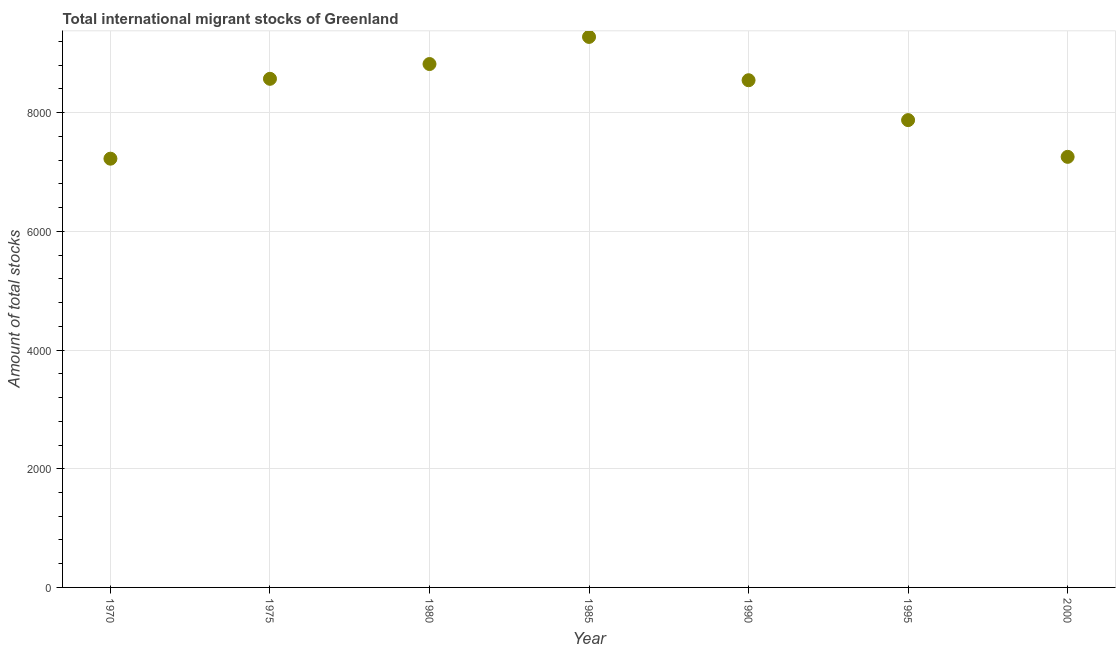What is the total number of international migrant stock in 1990?
Offer a terse response. 8547. Across all years, what is the maximum total number of international migrant stock?
Offer a terse response. 9277. Across all years, what is the minimum total number of international migrant stock?
Provide a short and direct response. 7225. In which year was the total number of international migrant stock maximum?
Your answer should be compact. 1985. What is the sum of the total number of international migrant stock?
Offer a terse response. 5.76e+04. What is the difference between the total number of international migrant stock in 1970 and 1980?
Make the answer very short. -1595. What is the average total number of international migrant stock per year?
Keep it short and to the point. 8224.43. What is the median total number of international migrant stock?
Offer a terse response. 8547. In how many years, is the total number of international migrant stock greater than 4400 ?
Provide a short and direct response. 7. What is the ratio of the total number of international migrant stock in 1975 to that in 1990?
Make the answer very short. 1. Is the difference between the total number of international migrant stock in 1970 and 1975 greater than the difference between any two years?
Give a very brief answer. No. What is the difference between the highest and the second highest total number of international migrant stock?
Your answer should be compact. 457. Is the sum of the total number of international migrant stock in 1970 and 1985 greater than the maximum total number of international migrant stock across all years?
Offer a very short reply. Yes. What is the difference between the highest and the lowest total number of international migrant stock?
Offer a terse response. 2052. Does the total number of international migrant stock monotonically increase over the years?
Offer a terse response. No. How many dotlines are there?
Offer a very short reply. 1. How many years are there in the graph?
Ensure brevity in your answer.  7. Does the graph contain any zero values?
Offer a very short reply. No. What is the title of the graph?
Provide a short and direct response. Total international migrant stocks of Greenland. What is the label or title of the Y-axis?
Your answer should be compact. Amount of total stocks. What is the Amount of total stocks in 1970?
Ensure brevity in your answer.  7225. What is the Amount of total stocks in 1975?
Give a very brief answer. 8571. What is the Amount of total stocks in 1980?
Your response must be concise. 8820. What is the Amount of total stocks in 1985?
Provide a short and direct response. 9277. What is the Amount of total stocks in 1990?
Keep it short and to the point. 8547. What is the Amount of total stocks in 1995?
Provide a succinct answer. 7875. What is the Amount of total stocks in 2000?
Your answer should be very brief. 7256. What is the difference between the Amount of total stocks in 1970 and 1975?
Make the answer very short. -1346. What is the difference between the Amount of total stocks in 1970 and 1980?
Your answer should be very brief. -1595. What is the difference between the Amount of total stocks in 1970 and 1985?
Offer a terse response. -2052. What is the difference between the Amount of total stocks in 1970 and 1990?
Give a very brief answer. -1322. What is the difference between the Amount of total stocks in 1970 and 1995?
Provide a short and direct response. -650. What is the difference between the Amount of total stocks in 1970 and 2000?
Your answer should be compact. -31. What is the difference between the Amount of total stocks in 1975 and 1980?
Provide a short and direct response. -249. What is the difference between the Amount of total stocks in 1975 and 1985?
Your answer should be very brief. -706. What is the difference between the Amount of total stocks in 1975 and 1995?
Offer a terse response. 696. What is the difference between the Amount of total stocks in 1975 and 2000?
Provide a succinct answer. 1315. What is the difference between the Amount of total stocks in 1980 and 1985?
Keep it short and to the point. -457. What is the difference between the Amount of total stocks in 1980 and 1990?
Offer a terse response. 273. What is the difference between the Amount of total stocks in 1980 and 1995?
Your response must be concise. 945. What is the difference between the Amount of total stocks in 1980 and 2000?
Your answer should be very brief. 1564. What is the difference between the Amount of total stocks in 1985 and 1990?
Your answer should be very brief. 730. What is the difference between the Amount of total stocks in 1985 and 1995?
Give a very brief answer. 1402. What is the difference between the Amount of total stocks in 1985 and 2000?
Make the answer very short. 2021. What is the difference between the Amount of total stocks in 1990 and 1995?
Your response must be concise. 672. What is the difference between the Amount of total stocks in 1990 and 2000?
Provide a succinct answer. 1291. What is the difference between the Amount of total stocks in 1995 and 2000?
Give a very brief answer. 619. What is the ratio of the Amount of total stocks in 1970 to that in 1975?
Give a very brief answer. 0.84. What is the ratio of the Amount of total stocks in 1970 to that in 1980?
Your answer should be compact. 0.82. What is the ratio of the Amount of total stocks in 1970 to that in 1985?
Your response must be concise. 0.78. What is the ratio of the Amount of total stocks in 1970 to that in 1990?
Ensure brevity in your answer.  0.84. What is the ratio of the Amount of total stocks in 1970 to that in 1995?
Provide a succinct answer. 0.92. What is the ratio of the Amount of total stocks in 1970 to that in 2000?
Offer a terse response. 1. What is the ratio of the Amount of total stocks in 1975 to that in 1980?
Provide a short and direct response. 0.97. What is the ratio of the Amount of total stocks in 1975 to that in 1985?
Give a very brief answer. 0.92. What is the ratio of the Amount of total stocks in 1975 to that in 1995?
Make the answer very short. 1.09. What is the ratio of the Amount of total stocks in 1975 to that in 2000?
Ensure brevity in your answer.  1.18. What is the ratio of the Amount of total stocks in 1980 to that in 1985?
Your response must be concise. 0.95. What is the ratio of the Amount of total stocks in 1980 to that in 1990?
Your answer should be very brief. 1.03. What is the ratio of the Amount of total stocks in 1980 to that in 1995?
Your answer should be compact. 1.12. What is the ratio of the Amount of total stocks in 1980 to that in 2000?
Your response must be concise. 1.22. What is the ratio of the Amount of total stocks in 1985 to that in 1990?
Offer a terse response. 1.08. What is the ratio of the Amount of total stocks in 1985 to that in 1995?
Offer a very short reply. 1.18. What is the ratio of the Amount of total stocks in 1985 to that in 2000?
Provide a succinct answer. 1.28. What is the ratio of the Amount of total stocks in 1990 to that in 1995?
Provide a short and direct response. 1.08. What is the ratio of the Amount of total stocks in 1990 to that in 2000?
Your answer should be compact. 1.18. What is the ratio of the Amount of total stocks in 1995 to that in 2000?
Offer a terse response. 1.08. 